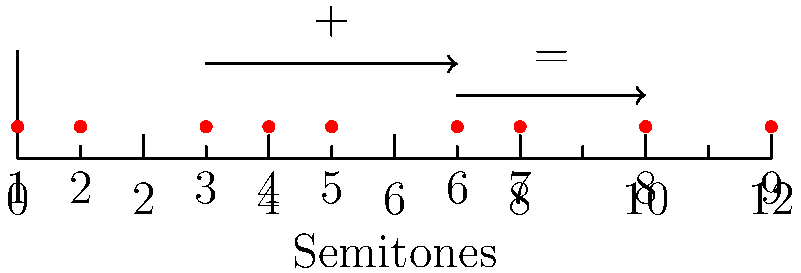In a Middle Eastern maqam scale used in your opera performances, the intervals between consecutive notes are represented by the sequence $(1,2,1,1,2,1,2,2)$ semitones. If we consider the group operation of interval addition modulo 12, what is the result of combining the fourth (4) and sixth (6) scale degrees? Let's approach this step-by-step:

1) First, we need to determine the semitone positions of each scale degree:
   1st: 0
   2nd: 1 (0 + 1)
   3rd: 3 (1 + 2)
   4th: 4 (3 + 1)
   5th: 5 (4 + 1)
   6th: 7 (5 + 2)
   7th: 8 (7 + 1)
   8th: 10 (8 + 2)
   9th: 12 (10 + 2) = 0 (modulo 12)

2) We're asked to combine the 4th and 6th scale degrees.
   4th degree is at position 4 semitones
   6th degree is at position 7 semitones

3) To combine them, we add their positions:
   4 + 7 = 11

4) In the group of interval addition modulo 12, 11 is a valid result and doesn't need further reduction.

5) To determine which scale degree this corresponds to, we look at our list from step 1.
   11 is not in our list, but it falls between 10 (8th degree) and 12 (9th degree, which is equivalent to 0).

6) Therefore, 11 semitones corresponds to the interval between the 8th and 9th scale degrees, which we can call the "augmented 8th" or "minor 9th" in musical terms.
Answer: 11 (augmented 8th/minor 9th) 